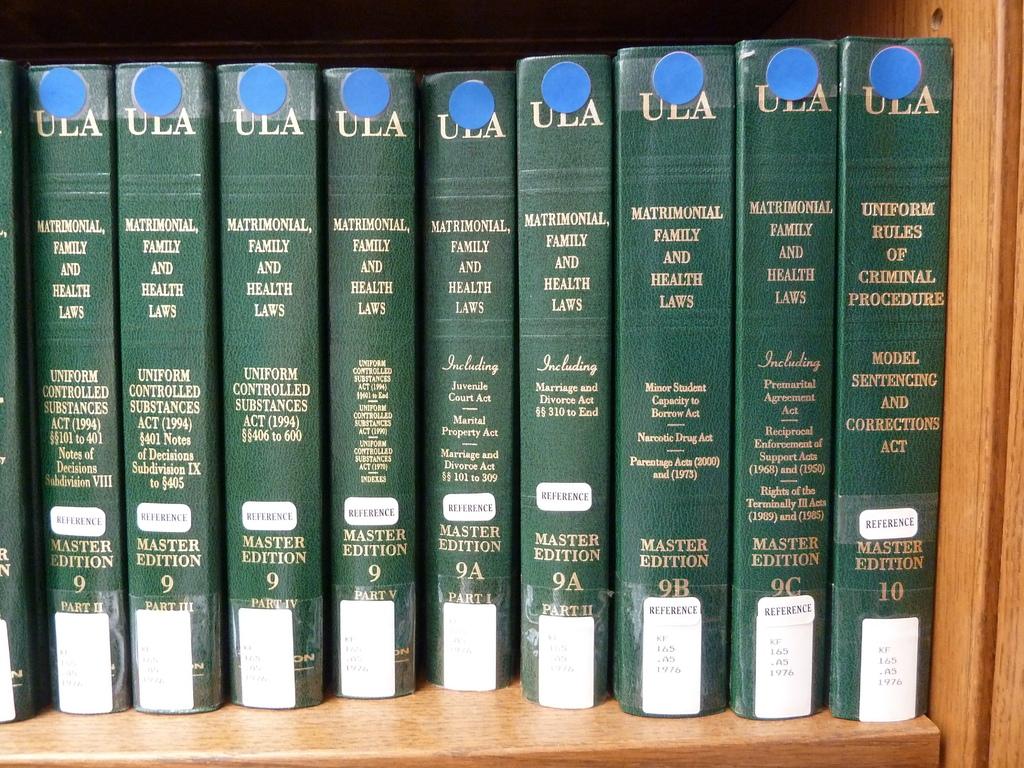What type of edition are these books?
Ensure brevity in your answer.  Master. What subject matter do the books cover?
Offer a terse response. Matrimonial, family and health laws. 